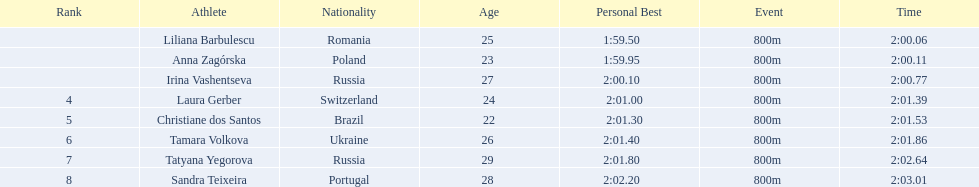Who were all of the athletes? Liliana Barbulescu, Anna Zagórska, Irina Vashentseva, Laura Gerber, Christiane dos Santos, Tamara Volkova, Tatyana Yegorova, Sandra Teixeira. What were their finishing times? 2:00.06, 2:00.11, 2:00.77, 2:01.39, 2:01.53, 2:01.86, 2:02.64, 2:03.01. Which athlete finished earliest? Liliana Barbulescu. 